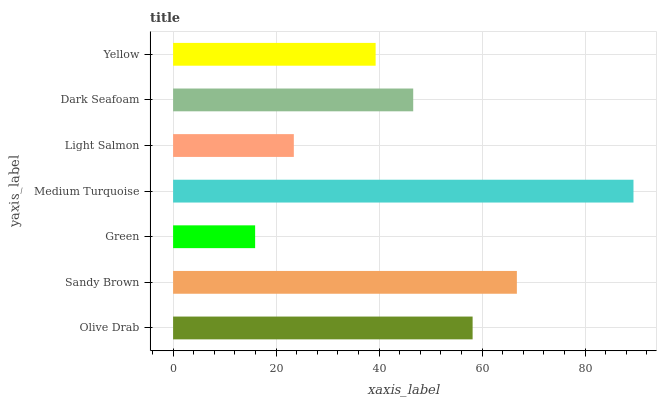Is Green the minimum?
Answer yes or no. Yes. Is Medium Turquoise the maximum?
Answer yes or no. Yes. Is Sandy Brown the minimum?
Answer yes or no. No. Is Sandy Brown the maximum?
Answer yes or no. No. Is Sandy Brown greater than Olive Drab?
Answer yes or no. Yes. Is Olive Drab less than Sandy Brown?
Answer yes or no. Yes. Is Olive Drab greater than Sandy Brown?
Answer yes or no. No. Is Sandy Brown less than Olive Drab?
Answer yes or no. No. Is Dark Seafoam the high median?
Answer yes or no. Yes. Is Dark Seafoam the low median?
Answer yes or no. Yes. Is Olive Drab the high median?
Answer yes or no. No. Is Light Salmon the low median?
Answer yes or no. No. 